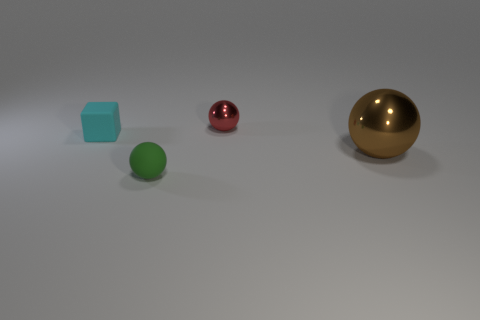Add 2 cyan metal cylinders. How many objects exist? 6 Subtract all tiny balls. How many balls are left? 1 Subtract all red balls. How many balls are left? 2 Subtract 0 purple cylinders. How many objects are left? 4 Subtract all cubes. How many objects are left? 3 Subtract all green cubes. Subtract all green cylinders. How many cubes are left? 1 Subtract all small gray metal things. Subtract all metallic balls. How many objects are left? 2 Add 3 matte objects. How many matte objects are left? 5 Add 1 red metal objects. How many red metal objects exist? 2 